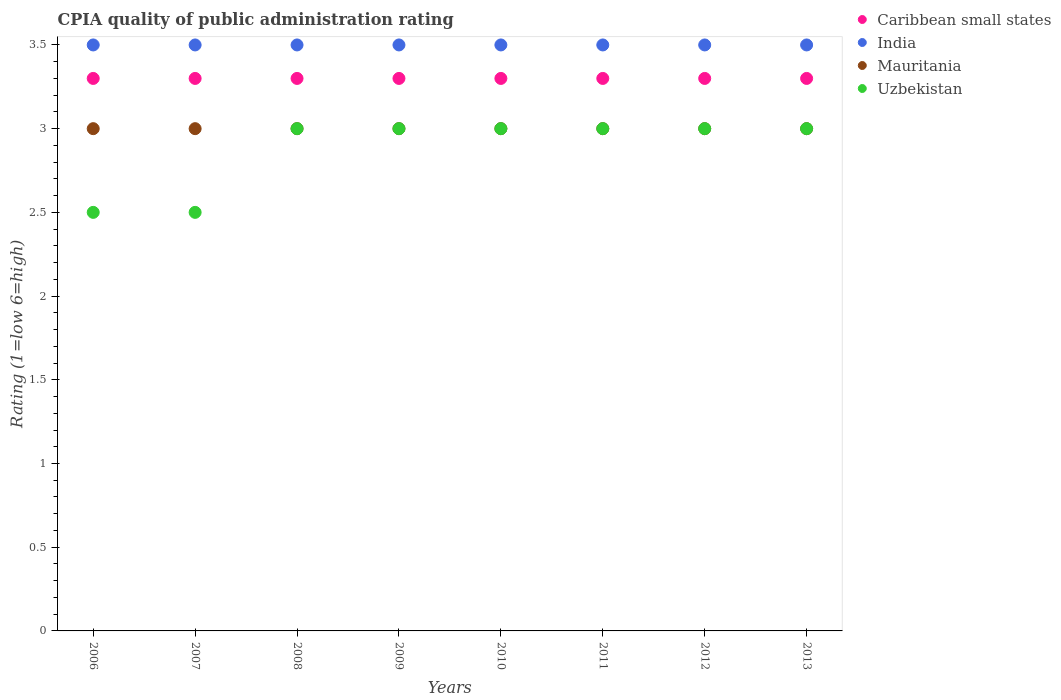How many different coloured dotlines are there?
Ensure brevity in your answer.  4. Is the number of dotlines equal to the number of legend labels?
Provide a succinct answer. Yes. Across all years, what is the maximum CPIA rating in Mauritania?
Offer a very short reply. 3. Across all years, what is the minimum CPIA rating in Mauritania?
Offer a terse response. 3. In which year was the CPIA rating in India minimum?
Ensure brevity in your answer.  2006. What is the difference between the CPIA rating in Caribbean small states in 2008 and the CPIA rating in Mauritania in 2010?
Keep it short and to the point. 0.3. In the year 2010, what is the difference between the CPIA rating in India and CPIA rating in Uzbekistan?
Make the answer very short. 0.5. In how many years, is the CPIA rating in Caribbean small states greater than 3.4?
Your answer should be compact. 0. What is the ratio of the CPIA rating in India in 2008 to that in 2009?
Make the answer very short. 1. Is the difference between the CPIA rating in India in 2007 and 2012 greater than the difference between the CPIA rating in Uzbekistan in 2007 and 2012?
Offer a terse response. Yes. What is the difference between the highest and the second highest CPIA rating in Caribbean small states?
Offer a very short reply. 0. Is it the case that in every year, the sum of the CPIA rating in Uzbekistan and CPIA rating in India  is greater than the sum of CPIA rating in Mauritania and CPIA rating in Caribbean small states?
Your answer should be compact. Yes. Is the CPIA rating in Caribbean small states strictly less than the CPIA rating in Uzbekistan over the years?
Your response must be concise. No. How many dotlines are there?
Your response must be concise. 4. Does the graph contain any zero values?
Offer a very short reply. No. How many legend labels are there?
Your answer should be very brief. 4. How are the legend labels stacked?
Make the answer very short. Vertical. What is the title of the graph?
Keep it short and to the point. CPIA quality of public administration rating. What is the label or title of the X-axis?
Provide a short and direct response. Years. What is the label or title of the Y-axis?
Give a very brief answer. Rating (1=low 6=high). What is the Rating (1=low 6=high) of India in 2006?
Offer a terse response. 3.5. What is the Rating (1=low 6=high) in India in 2007?
Your answer should be compact. 3.5. What is the Rating (1=low 6=high) of Mauritania in 2007?
Make the answer very short. 3. What is the Rating (1=low 6=high) of Caribbean small states in 2008?
Offer a very short reply. 3.3. What is the Rating (1=low 6=high) in India in 2008?
Provide a succinct answer. 3.5. What is the Rating (1=low 6=high) in Mauritania in 2008?
Offer a very short reply. 3. What is the Rating (1=low 6=high) of Mauritania in 2009?
Ensure brevity in your answer.  3. What is the Rating (1=low 6=high) in Uzbekistan in 2009?
Offer a terse response. 3. What is the Rating (1=low 6=high) in Uzbekistan in 2010?
Give a very brief answer. 3. What is the Rating (1=low 6=high) of Caribbean small states in 2011?
Keep it short and to the point. 3.3. What is the Rating (1=low 6=high) in India in 2011?
Offer a very short reply. 3.5. What is the Rating (1=low 6=high) in India in 2012?
Your response must be concise. 3.5. What is the Rating (1=low 6=high) of Mauritania in 2012?
Provide a succinct answer. 3. What is the Rating (1=low 6=high) of Caribbean small states in 2013?
Your answer should be compact. 3.3. What is the Rating (1=low 6=high) in India in 2013?
Make the answer very short. 3.5. Across all years, what is the maximum Rating (1=low 6=high) in Mauritania?
Offer a very short reply. 3. Across all years, what is the minimum Rating (1=low 6=high) in Caribbean small states?
Offer a terse response. 3.3. Across all years, what is the minimum Rating (1=low 6=high) in Uzbekistan?
Provide a succinct answer. 2.5. What is the total Rating (1=low 6=high) in Caribbean small states in the graph?
Your response must be concise. 26.4. What is the total Rating (1=low 6=high) in India in the graph?
Your answer should be very brief. 28. What is the difference between the Rating (1=low 6=high) of Caribbean small states in 2006 and that in 2007?
Your response must be concise. 0. What is the difference between the Rating (1=low 6=high) in India in 2006 and that in 2007?
Provide a succinct answer. 0. What is the difference between the Rating (1=low 6=high) in Mauritania in 2006 and that in 2007?
Provide a short and direct response. 0. What is the difference between the Rating (1=low 6=high) of Uzbekistan in 2006 and that in 2007?
Make the answer very short. 0. What is the difference between the Rating (1=low 6=high) in India in 2006 and that in 2008?
Provide a succinct answer. 0. What is the difference between the Rating (1=low 6=high) in Uzbekistan in 2006 and that in 2009?
Provide a succinct answer. -0.5. What is the difference between the Rating (1=low 6=high) in Caribbean small states in 2006 and that in 2010?
Provide a succinct answer. 0. What is the difference between the Rating (1=low 6=high) in India in 2006 and that in 2010?
Give a very brief answer. 0. What is the difference between the Rating (1=low 6=high) in Mauritania in 2006 and that in 2010?
Keep it short and to the point. 0. What is the difference between the Rating (1=low 6=high) in Uzbekistan in 2006 and that in 2011?
Your response must be concise. -0.5. What is the difference between the Rating (1=low 6=high) of Caribbean small states in 2006 and that in 2012?
Keep it short and to the point. 0. What is the difference between the Rating (1=low 6=high) of Mauritania in 2006 and that in 2012?
Give a very brief answer. 0. What is the difference between the Rating (1=low 6=high) of Uzbekistan in 2006 and that in 2012?
Provide a succinct answer. -0.5. What is the difference between the Rating (1=low 6=high) in Caribbean small states in 2006 and that in 2013?
Your answer should be very brief. 0. What is the difference between the Rating (1=low 6=high) in Mauritania in 2006 and that in 2013?
Make the answer very short. 0. What is the difference between the Rating (1=low 6=high) in Mauritania in 2007 and that in 2008?
Your answer should be very brief. 0. What is the difference between the Rating (1=low 6=high) in Caribbean small states in 2007 and that in 2009?
Your answer should be compact. 0. What is the difference between the Rating (1=low 6=high) in India in 2007 and that in 2009?
Give a very brief answer. 0. What is the difference between the Rating (1=low 6=high) in India in 2007 and that in 2010?
Your response must be concise. 0. What is the difference between the Rating (1=low 6=high) in Caribbean small states in 2007 and that in 2011?
Your answer should be very brief. 0. What is the difference between the Rating (1=low 6=high) in India in 2007 and that in 2011?
Your answer should be very brief. 0. What is the difference between the Rating (1=low 6=high) in Mauritania in 2007 and that in 2011?
Provide a succinct answer. 0. What is the difference between the Rating (1=low 6=high) in India in 2007 and that in 2012?
Provide a short and direct response. 0. What is the difference between the Rating (1=low 6=high) of Mauritania in 2007 and that in 2012?
Your answer should be very brief. 0. What is the difference between the Rating (1=low 6=high) of Mauritania in 2007 and that in 2013?
Make the answer very short. 0. What is the difference between the Rating (1=low 6=high) of Mauritania in 2008 and that in 2009?
Offer a very short reply. 0. What is the difference between the Rating (1=low 6=high) in Uzbekistan in 2008 and that in 2009?
Your answer should be very brief. 0. What is the difference between the Rating (1=low 6=high) of Caribbean small states in 2008 and that in 2010?
Your answer should be compact. 0. What is the difference between the Rating (1=low 6=high) in India in 2008 and that in 2010?
Provide a succinct answer. 0. What is the difference between the Rating (1=low 6=high) of Mauritania in 2008 and that in 2010?
Provide a succinct answer. 0. What is the difference between the Rating (1=low 6=high) in Caribbean small states in 2008 and that in 2011?
Give a very brief answer. 0. What is the difference between the Rating (1=low 6=high) of India in 2008 and that in 2011?
Make the answer very short. 0. What is the difference between the Rating (1=low 6=high) of Mauritania in 2008 and that in 2011?
Provide a succinct answer. 0. What is the difference between the Rating (1=low 6=high) of Uzbekistan in 2008 and that in 2011?
Provide a short and direct response. 0. What is the difference between the Rating (1=low 6=high) in India in 2008 and that in 2012?
Ensure brevity in your answer.  0. What is the difference between the Rating (1=low 6=high) of Uzbekistan in 2008 and that in 2012?
Ensure brevity in your answer.  0. What is the difference between the Rating (1=low 6=high) of Caribbean small states in 2008 and that in 2013?
Offer a terse response. 0. What is the difference between the Rating (1=low 6=high) of India in 2008 and that in 2013?
Keep it short and to the point. 0. What is the difference between the Rating (1=low 6=high) in Uzbekistan in 2008 and that in 2013?
Ensure brevity in your answer.  0. What is the difference between the Rating (1=low 6=high) in Caribbean small states in 2009 and that in 2010?
Keep it short and to the point. 0. What is the difference between the Rating (1=low 6=high) in India in 2009 and that in 2010?
Keep it short and to the point. 0. What is the difference between the Rating (1=low 6=high) of Caribbean small states in 2009 and that in 2011?
Ensure brevity in your answer.  0. What is the difference between the Rating (1=low 6=high) in Mauritania in 2009 and that in 2011?
Provide a short and direct response. 0. What is the difference between the Rating (1=low 6=high) of Uzbekistan in 2009 and that in 2011?
Provide a succinct answer. 0. What is the difference between the Rating (1=low 6=high) of Caribbean small states in 2009 and that in 2012?
Give a very brief answer. 0. What is the difference between the Rating (1=low 6=high) in India in 2009 and that in 2012?
Ensure brevity in your answer.  0. What is the difference between the Rating (1=low 6=high) in Mauritania in 2009 and that in 2012?
Provide a succinct answer. 0. What is the difference between the Rating (1=low 6=high) of Uzbekistan in 2009 and that in 2013?
Your answer should be compact. 0. What is the difference between the Rating (1=low 6=high) in India in 2010 and that in 2011?
Ensure brevity in your answer.  0. What is the difference between the Rating (1=low 6=high) in Uzbekistan in 2010 and that in 2011?
Give a very brief answer. 0. What is the difference between the Rating (1=low 6=high) of Caribbean small states in 2010 and that in 2012?
Provide a short and direct response. 0. What is the difference between the Rating (1=low 6=high) in Mauritania in 2010 and that in 2012?
Make the answer very short. 0. What is the difference between the Rating (1=low 6=high) of India in 2010 and that in 2013?
Give a very brief answer. 0. What is the difference between the Rating (1=low 6=high) in India in 2011 and that in 2012?
Your answer should be very brief. 0. What is the difference between the Rating (1=low 6=high) in Mauritania in 2011 and that in 2012?
Ensure brevity in your answer.  0. What is the difference between the Rating (1=low 6=high) of Caribbean small states in 2011 and that in 2013?
Make the answer very short. 0. What is the difference between the Rating (1=low 6=high) in Caribbean small states in 2012 and that in 2013?
Your answer should be very brief. 0. What is the difference between the Rating (1=low 6=high) in Mauritania in 2012 and that in 2013?
Offer a very short reply. 0. What is the difference between the Rating (1=low 6=high) in Uzbekistan in 2012 and that in 2013?
Offer a terse response. 0. What is the difference between the Rating (1=low 6=high) of Caribbean small states in 2006 and the Rating (1=low 6=high) of Mauritania in 2007?
Provide a succinct answer. 0.3. What is the difference between the Rating (1=low 6=high) in India in 2006 and the Rating (1=low 6=high) in Mauritania in 2007?
Provide a succinct answer. 0.5. What is the difference between the Rating (1=low 6=high) of India in 2006 and the Rating (1=low 6=high) of Uzbekistan in 2007?
Provide a succinct answer. 1. What is the difference between the Rating (1=low 6=high) of Mauritania in 2006 and the Rating (1=low 6=high) of Uzbekistan in 2007?
Provide a short and direct response. 0.5. What is the difference between the Rating (1=low 6=high) in Caribbean small states in 2006 and the Rating (1=low 6=high) in Mauritania in 2008?
Provide a succinct answer. 0.3. What is the difference between the Rating (1=low 6=high) of Caribbean small states in 2006 and the Rating (1=low 6=high) of Mauritania in 2009?
Your answer should be compact. 0.3. What is the difference between the Rating (1=low 6=high) of Caribbean small states in 2006 and the Rating (1=low 6=high) of Uzbekistan in 2009?
Provide a short and direct response. 0.3. What is the difference between the Rating (1=low 6=high) in India in 2006 and the Rating (1=low 6=high) in Mauritania in 2009?
Your answer should be very brief. 0.5. What is the difference between the Rating (1=low 6=high) in India in 2006 and the Rating (1=low 6=high) in Uzbekistan in 2009?
Offer a very short reply. 0.5. What is the difference between the Rating (1=low 6=high) in Caribbean small states in 2006 and the Rating (1=low 6=high) in India in 2010?
Provide a succinct answer. -0.2. What is the difference between the Rating (1=low 6=high) in Caribbean small states in 2006 and the Rating (1=low 6=high) in Uzbekistan in 2011?
Give a very brief answer. 0.3. What is the difference between the Rating (1=low 6=high) of India in 2006 and the Rating (1=low 6=high) of Mauritania in 2011?
Ensure brevity in your answer.  0.5. What is the difference between the Rating (1=low 6=high) of India in 2006 and the Rating (1=low 6=high) of Uzbekistan in 2011?
Your answer should be compact. 0.5. What is the difference between the Rating (1=low 6=high) of Mauritania in 2006 and the Rating (1=low 6=high) of Uzbekistan in 2011?
Your answer should be compact. 0. What is the difference between the Rating (1=low 6=high) in Caribbean small states in 2006 and the Rating (1=low 6=high) in India in 2012?
Give a very brief answer. -0.2. What is the difference between the Rating (1=low 6=high) in Caribbean small states in 2006 and the Rating (1=low 6=high) in Mauritania in 2012?
Provide a short and direct response. 0.3. What is the difference between the Rating (1=low 6=high) in Caribbean small states in 2006 and the Rating (1=low 6=high) in Uzbekistan in 2012?
Ensure brevity in your answer.  0.3. What is the difference between the Rating (1=low 6=high) in India in 2006 and the Rating (1=low 6=high) in Mauritania in 2012?
Provide a short and direct response. 0.5. What is the difference between the Rating (1=low 6=high) of India in 2006 and the Rating (1=low 6=high) of Uzbekistan in 2012?
Ensure brevity in your answer.  0.5. What is the difference between the Rating (1=low 6=high) in Caribbean small states in 2006 and the Rating (1=low 6=high) in India in 2013?
Keep it short and to the point. -0.2. What is the difference between the Rating (1=low 6=high) of Caribbean small states in 2006 and the Rating (1=low 6=high) of Mauritania in 2013?
Ensure brevity in your answer.  0.3. What is the difference between the Rating (1=low 6=high) of Caribbean small states in 2007 and the Rating (1=low 6=high) of Mauritania in 2008?
Make the answer very short. 0.3. What is the difference between the Rating (1=low 6=high) in India in 2007 and the Rating (1=low 6=high) in Mauritania in 2008?
Your response must be concise. 0.5. What is the difference between the Rating (1=low 6=high) in India in 2007 and the Rating (1=low 6=high) in Mauritania in 2009?
Provide a short and direct response. 0.5. What is the difference between the Rating (1=low 6=high) of India in 2007 and the Rating (1=low 6=high) of Uzbekistan in 2009?
Ensure brevity in your answer.  0.5. What is the difference between the Rating (1=low 6=high) of Caribbean small states in 2007 and the Rating (1=low 6=high) of India in 2010?
Provide a short and direct response. -0.2. What is the difference between the Rating (1=low 6=high) in Caribbean small states in 2007 and the Rating (1=low 6=high) in Mauritania in 2010?
Your response must be concise. 0.3. What is the difference between the Rating (1=low 6=high) in India in 2007 and the Rating (1=low 6=high) in Uzbekistan in 2010?
Keep it short and to the point. 0.5. What is the difference between the Rating (1=low 6=high) of Caribbean small states in 2007 and the Rating (1=low 6=high) of India in 2011?
Provide a short and direct response. -0.2. What is the difference between the Rating (1=low 6=high) in Caribbean small states in 2007 and the Rating (1=low 6=high) in Uzbekistan in 2011?
Your answer should be very brief. 0.3. What is the difference between the Rating (1=low 6=high) of India in 2007 and the Rating (1=low 6=high) of Uzbekistan in 2011?
Offer a terse response. 0.5. What is the difference between the Rating (1=low 6=high) in Caribbean small states in 2007 and the Rating (1=low 6=high) in India in 2012?
Offer a very short reply. -0.2. What is the difference between the Rating (1=low 6=high) of Caribbean small states in 2007 and the Rating (1=low 6=high) of Uzbekistan in 2012?
Offer a very short reply. 0.3. What is the difference between the Rating (1=low 6=high) in India in 2007 and the Rating (1=low 6=high) in Mauritania in 2012?
Give a very brief answer. 0.5. What is the difference between the Rating (1=low 6=high) in Caribbean small states in 2007 and the Rating (1=low 6=high) in India in 2013?
Your answer should be very brief. -0.2. What is the difference between the Rating (1=low 6=high) in Caribbean small states in 2007 and the Rating (1=low 6=high) in Mauritania in 2013?
Your answer should be compact. 0.3. What is the difference between the Rating (1=low 6=high) in Caribbean small states in 2007 and the Rating (1=low 6=high) in Uzbekistan in 2013?
Offer a very short reply. 0.3. What is the difference between the Rating (1=low 6=high) in Mauritania in 2007 and the Rating (1=low 6=high) in Uzbekistan in 2013?
Give a very brief answer. 0. What is the difference between the Rating (1=low 6=high) of Caribbean small states in 2008 and the Rating (1=low 6=high) of Mauritania in 2009?
Your answer should be very brief. 0.3. What is the difference between the Rating (1=low 6=high) in Caribbean small states in 2008 and the Rating (1=low 6=high) in Uzbekistan in 2009?
Make the answer very short. 0.3. What is the difference between the Rating (1=low 6=high) of India in 2008 and the Rating (1=low 6=high) of Mauritania in 2009?
Offer a terse response. 0.5. What is the difference between the Rating (1=low 6=high) in India in 2008 and the Rating (1=low 6=high) in Uzbekistan in 2009?
Your answer should be very brief. 0.5. What is the difference between the Rating (1=low 6=high) in Caribbean small states in 2008 and the Rating (1=low 6=high) in Mauritania in 2010?
Your answer should be very brief. 0.3. What is the difference between the Rating (1=low 6=high) in Caribbean small states in 2008 and the Rating (1=low 6=high) in Uzbekistan in 2010?
Ensure brevity in your answer.  0.3. What is the difference between the Rating (1=low 6=high) in India in 2008 and the Rating (1=low 6=high) in Uzbekistan in 2010?
Your answer should be compact. 0.5. What is the difference between the Rating (1=low 6=high) in Caribbean small states in 2008 and the Rating (1=low 6=high) in Mauritania in 2011?
Keep it short and to the point. 0.3. What is the difference between the Rating (1=low 6=high) of Caribbean small states in 2008 and the Rating (1=low 6=high) of Uzbekistan in 2011?
Keep it short and to the point. 0.3. What is the difference between the Rating (1=low 6=high) of India in 2008 and the Rating (1=low 6=high) of Uzbekistan in 2011?
Offer a terse response. 0.5. What is the difference between the Rating (1=low 6=high) of Mauritania in 2008 and the Rating (1=low 6=high) of Uzbekistan in 2011?
Your response must be concise. 0. What is the difference between the Rating (1=low 6=high) of Caribbean small states in 2008 and the Rating (1=low 6=high) of India in 2012?
Give a very brief answer. -0.2. What is the difference between the Rating (1=low 6=high) of Caribbean small states in 2008 and the Rating (1=low 6=high) of Mauritania in 2012?
Your response must be concise. 0.3. What is the difference between the Rating (1=low 6=high) of Mauritania in 2008 and the Rating (1=low 6=high) of Uzbekistan in 2012?
Offer a very short reply. 0. What is the difference between the Rating (1=low 6=high) of Caribbean small states in 2008 and the Rating (1=low 6=high) of Uzbekistan in 2013?
Provide a short and direct response. 0.3. What is the difference between the Rating (1=low 6=high) of India in 2008 and the Rating (1=low 6=high) of Mauritania in 2013?
Your answer should be very brief. 0.5. What is the difference between the Rating (1=low 6=high) in India in 2008 and the Rating (1=low 6=high) in Uzbekistan in 2013?
Your answer should be compact. 0.5. What is the difference between the Rating (1=low 6=high) of Mauritania in 2008 and the Rating (1=low 6=high) of Uzbekistan in 2013?
Provide a short and direct response. 0. What is the difference between the Rating (1=low 6=high) in Caribbean small states in 2009 and the Rating (1=low 6=high) in India in 2010?
Ensure brevity in your answer.  -0.2. What is the difference between the Rating (1=low 6=high) in Caribbean small states in 2009 and the Rating (1=low 6=high) in Uzbekistan in 2010?
Make the answer very short. 0.3. What is the difference between the Rating (1=low 6=high) in Caribbean small states in 2009 and the Rating (1=low 6=high) in Uzbekistan in 2011?
Offer a terse response. 0.3. What is the difference between the Rating (1=low 6=high) of India in 2009 and the Rating (1=low 6=high) of Mauritania in 2011?
Keep it short and to the point. 0.5. What is the difference between the Rating (1=low 6=high) in Mauritania in 2009 and the Rating (1=low 6=high) in Uzbekistan in 2011?
Offer a terse response. 0. What is the difference between the Rating (1=low 6=high) of Caribbean small states in 2009 and the Rating (1=low 6=high) of India in 2012?
Offer a very short reply. -0.2. What is the difference between the Rating (1=low 6=high) in India in 2009 and the Rating (1=low 6=high) in Mauritania in 2012?
Provide a short and direct response. 0.5. What is the difference between the Rating (1=low 6=high) of India in 2009 and the Rating (1=low 6=high) of Uzbekistan in 2012?
Give a very brief answer. 0.5. What is the difference between the Rating (1=low 6=high) of Caribbean small states in 2009 and the Rating (1=low 6=high) of India in 2013?
Keep it short and to the point. -0.2. What is the difference between the Rating (1=low 6=high) in Caribbean small states in 2009 and the Rating (1=low 6=high) in Mauritania in 2013?
Your answer should be compact. 0.3. What is the difference between the Rating (1=low 6=high) of India in 2009 and the Rating (1=low 6=high) of Mauritania in 2013?
Your answer should be very brief. 0.5. What is the difference between the Rating (1=low 6=high) in India in 2009 and the Rating (1=low 6=high) in Uzbekistan in 2013?
Ensure brevity in your answer.  0.5. What is the difference between the Rating (1=low 6=high) in Mauritania in 2009 and the Rating (1=low 6=high) in Uzbekistan in 2013?
Provide a succinct answer. 0. What is the difference between the Rating (1=low 6=high) in Caribbean small states in 2010 and the Rating (1=low 6=high) in India in 2011?
Provide a short and direct response. -0.2. What is the difference between the Rating (1=low 6=high) in Mauritania in 2010 and the Rating (1=low 6=high) in Uzbekistan in 2011?
Make the answer very short. 0. What is the difference between the Rating (1=low 6=high) of Caribbean small states in 2010 and the Rating (1=low 6=high) of India in 2012?
Your answer should be very brief. -0.2. What is the difference between the Rating (1=low 6=high) in Caribbean small states in 2010 and the Rating (1=low 6=high) in Mauritania in 2012?
Offer a terse response. 0.3. What is the difference between the Rating (1=low 6=high) in Caribbean small states in 2010 and the Rating (1=low 6=high) in Uzbekistan in 2012?
Give a very brief answer. 0.3. What is the difference between the Rating (1=low 6=high) of India in 2010 and the Rating (1=low 6=high) of Mauritania in 2012?
Give a very brief answer. 0.5. What is the difference between the Rating (1=low 6=high) in India in 2010 and the Rating (1=low 6=high) in Uzbekistan in 2012?
Give a very brief answer. 0.5. What is the difference between the Rating (1=low 6=high) in Mauritania in 2010 and the Rating (1=low 6=high) in Uzbekistan in 2012?
Offer a terse response. 0. What is the difference between the Rating (1=low 6=high) of Caribbean small states in 2010 and the Rating (1=low 6=high) of India in 2013?
Provide a short and direct response. -0.2. What is the difference between the Rating (1=low 6=high) in Caribbean small states in 2010 and the Rating (1=low 6=high) in Mauritania in 2013?
Provide a succinct answer. 0.3. What is the difference between the Rating (1=low 6=high) in Caribbean small states in 2010 and the Rating (1=low 6=high) in Uzbekistan in 2013?
Provide a short and direct response. 0.3. What is the difference between the Rating (1=low 6=high) of India in 2010 and the Rating (1=low 6=high) of Mauritania in 2013?
Provide a succinct answer. 0.5. What is the difference between the Rating (1=low 6=high) of Mauritania in 2010 and the Rating (1=low 6=high) of Uzbekistan in 2013?
Keep it short and to the point. 0. What is the difference between the Rating (1=low 6=high) of Caribbean small states in 2011 and the Rating (1=low 6=high) of Uzbekistan in 2012?
Make the answer very short. 0.3. What is the difference between the Rating (1=low 6=high) of India in 2011 and the Rating (1=low 6=high) of Uzbekistan in 2012?
Your answer should be very brief. 0.5. What is the difference between the Rating (1=low 6=high) of Mauritania in 2011 and the Rating (1=low 6=high) of Uzbekistan in 2012?
Provide a succinct answer. 0. What is the difference between the Rating (1=low 6=high) in Caribbean small states in 2011 and the Rating (1=low 6=high) in India in 2013?
Provide a short and direct response. -0.2. What is the difference between the Rating (1=low 6=high) of Caribbean small states in 2011 and the Rating (1=low 6=high) of Mauritania in 2013?
Your answer should be very brief. 0.3. What is the difference between the Rating (1=low 6=high) of India in 2011 and the Rating (1=low 6=high) of Mauritania in 2013?
Keep it short and to the point. 0.5. What is the difference between the Rating (1=low 6=high) of India in 2011 and the Rating (1=low 6=high) of Uzbekistan in 2013?
Ensure brevity in your answer.  0.5. What is the difference between the Rating (1=low 6=high) of Mauritania in 2011 and the Rating (1=low 6=high) of Uzbekistan in 2013?
Your response must be concise. 0. What is the difference between the Rating (1=low 6=high) of Caribbean small states in 2012 and the Rating (1=low 6=high) of India in 2013?
Your answer should be compact. -0.2. What is the difference between the Rating (1=low 6=high) in Caribbean small states in 2012 and the Rating (1=low 6=high) in Uzbekistan in 2013?
Keep it short and to the point. 0.3. What is the difference between the Rating (1=low 6=high) in India in 2012 and the Rating (1=low 6=high) in Mauritania in 2013?
Give a very brief answer. 0.5. What is the difference between the Rating (1=low 6=high) of Mauritania in 2012 and the Rating (1=low 6=high) of Uzbekistan in 2013?
Offer a very short reply. 0. What is the average Rating (1=low 6=high) of Caribbean small states per year?
Offer a very short reply. 3.3. What is the average Rating (1=low 6=high) in India per year?
Ensure brevity in your answer.  3.5. What is the average Rating (1=low 6=high) of Uzbekistan per year?
Offer a very short reply. 2.88. In the year 2006, what is the difference between the Rating (1=low 6=high) of Caribbean small states and Rating (1=low 6=high) of India?
Provide a short and direct response. -0.2. In the year 2006, what is the difference between the Rating (1=low 6=high) in Caribbean small states and Rating (1=low 6=high) in Uzbekistan?
Keep it short and to the point. 0.8. In the year 2007, what is the difference between the Rating (1=low 6=high) in Caribbean small states and Rating (1=low 6=high) in Uzbekistan?
Offer a very short reply. 0.8. In the year 2007, what is the difference between the Rating (1=low 6=high) of India and Rating (1=low 6=high) of Mauritania?
Your response must be concise. 0.5. In the year 2008, what is the difference between the Rating (1=low 6=high) of Caribbean small states and Rating (1=low 6=high) of India?
Offer a very short reply. -0.2. In the year 2008, what is the difference between the Rating (1=low 6=high) of India and Rating (1=low 6=high) of Mauritania?
Provide a succinct answer. 0.5. In the year 2008, what is the difference between the Rating (1=low 6=high) of India and Rating (1=low 6=high) of Uzbekistan?
Provide a succinct answer. 0.5. In the year 2009, what is the difference between the Rating (1=low 6=high) in Caribbean small states and Rating (1=low 6=high) in India?
Give a very brief answer. -0.2. In the year 2009, what is the difference between the Rating (1=low 6=high) of Caribbean small states and Rating (1=low 6=high) of Mauritania?
Your response must be concise. 0.3. In the year 2009, what is the difference between the Rating (1=low 6=high) in India and Rating (1=low 6=high) in Uzbekistan?
Make the answer very short. 0.5. In the year 2010, what is the difference between the Rating (1=low 6=high) of Caribbean small states and Rating (1=low 6=high) of India?
Make the answer very short. -0.2. In the year 2010, what is the difference between the Rating (1=low 6=high) in Caribbean small states and Rating (1=low 6=high) in Mauritania?
Make the answer very short. 0.3. In the year 2010, what is the difference between the Rating (1=low 6=high) of India and Rating (1=low 6=high) of Mauritania?
Offer a terse response. 0.5. In the year 2011, what is the difference between the Rating (1=low 6=high) of Caribbean small states and Rating (1=low 6=high) of India?
Your response must be concise. -0.2. In the year 2011, what is the difference between the Rating (1=low 6=high) in Caribbean small states and Rating (1=low 6=high) in Uzbekistan?
Provide a succinct answer. 0.3. In the year 2011, what is the difference between the Rating (1=low 6=high) in India and Rating (1=low 6=high) in Mauritania?
Offer a very short reply. 0.5. In the year 2011, what is the difference between the Rating (1=low 6=high) in India and Rating (1=low 6=high) in Uzbekistan?
Your response must be concise. 0.5. In the year 2012, what is the difference between the Rating (1=low 6=high) in Caribbean small states and Rating (1=low 6=high) in Mauritania?
Give a very brief answer. 0.3. In the year 2012, what is the difference between the Rating (1=low 6=high) of Caribbean small states and Rating (1=low 6=high) of Uzbekistan?
Give a very brief answer. 0.3. In the year 2012, what is the difference between the Rating (1=low 6=high) in Mauritania and Rating (1=low 6=high) in Uzbekistan?
Ensure brevity in your answer.  0. In the year 2013, what is the difference between the Rating (1=low 6=high) of Caribbean small states and Rating (1=low 6=high) of Mauritania?
Provide a short and direct response. 0.3. In the year 2013, what is the difference between the Rating (1=low 6=high) in India and Rating (1=low 6=high) in Mauritania?
Make the answer very short. 0.5. In the year 2013, what is the difference between the Rating (1=low 6=high) of India and Rating (1=low 6=high) of Uzbekistan?
Give a very brief answer. 0.5. What is the ratio of the Rating (1=low 6=high) in Caribbean small states in 2006 to that in 2007?
Offer a very short reply. 1. What is the ratio of the Rating (1=low 6=high) in India in 2006 to that in 2007?
Your response must be concise. 1. What is the ratio of the Rating (1=low 6=high) of Caribbean small states in 2006 to that in 2008?
Your answer should be very brief. 1. What is the ratio of the Rating (1=low 6=high) of India in 2006 to that in 2008?
Provide a short and direct response. 1. What is the ratio of the Rating (1=low 6=high) in Uzbekistan in 2006 to that in 2008?
Provide a short and direct response. 0.83. What is the ratio of the Rating (1=low 6=high) in Mauritania in 2006 to that in 2009?
Provide a succinct answer. 1. What is the ratio of the Rating (1=low 6=high) in Uzbekistan in 2006 to that in 2009?
Offer a terse response. 0.83. What is the ratio of the Rating (1=low 6=high) of Caribbean small states in 2006 to that in 2010?
Make the answer very short. 1. What is the ratio of the Rating (1=low 6=high) in India in 2006 to that in 2010?
Ensure brevity in your answer.  1. What is the ratio of the Rating (1=low 6=high) of Uzbekistan in 2006 to that in 2010?
Provide a short and direct response. 0.83. What is the ratio of the Rating (1=low 6=high) of Caribbean small states in 2006 to that in 2011?
Offer a very short reply. 1. What is the ratio of the Rating (1=low 6=high) of Mauritania in 2006 to that in 2011?
Offer a terse response. 1. What is the ratio of the Rating (1=low 6=high) of Uzbekistan in 2006 to that in 2011?
Offer a very short reply. 0.83. What is the ratio of the Rating (1=low 6=high) in Caribbean small states in 2006 to that in 2012?
Provide a short and direct response. 1. What is the ratio of the Rating (1=low 6=high) of Uzbekistan in 2006 to that in 2012?
Your answer should be very brief. 0.83. What is the ratio of the Rating (1=low 6=high) of India in 2006 to that in 2013?
Keep it short and to the point. 1. What is the ratio of the Rating (1=low 6=high) of Uzbekistan in 2006 to that in 2013?
Make the answer very short. 0.83. What is the ratio of the Rating (1=low 6=high) of India in 2007 to that in 2008?
Keep it short and to the point. 1. What is the ratio of the Rating (1=low 6=high) of Mauritania in 2007 to that in 2008?
Provide a succinct answer. 1. What is the ratio of the Rating (1=low 6=high) of Uzbekistan in 2007 to that in 2008?
Your answer should be very brief. 0.83. What is the ratio of the Rating (1=low 6=high) in Caribbean small states in 2007 to that in 2009?
Keep it short and to the point. 1. What is the ratio of the Rating (1=low 6=high) in India in 2007 to that in 2009?
Ensure brevity in your answer.  1. What is the ratio of the Rating (1=low 6=high) in Caribbean small states in 2007 to that in 2010?
Your answer should be very brief. 1. What is the ratio of the Rating (1=low 6=high) of India in 2007 to that in 2010?
Ensure brevity in your answer.  1. What is the ratio of the Rating (1=low 6=high) in Mauritania in 2007 to that in 2010?
Your answer should be very brief. 1. What is the ratio of the Rating (1=low 6=high) of Uzbekistan in 2007 to that in 2010?
Provide a succinct answer. 0.83. What is the ratio of the Rating (1=low 6=high) of Caribbean small states in 2007 to that in 2011?
Make the answer very short. 1. What is the ratio of the Rating (1=low 6=high) in Mauritania in 2007 to that in 2011?
Provide a succinct answer. 1. What is the ratio of the Rating (1=low 6=high) of Uzbekistan in 2007 to that in 2011?
Provide a succinct answer. 0.83. What is the ratio of the Rating (1=low 6=high) in India in 2007 to that in 2012?
Make the answer very short. 1. What is the ratio of the Rating (1=low 6=high) in Mauritania in 2007 to that in 2012?
Give a very brief answer. 1. What is the ratio of the Rating (1=low 6=high) in Caribbean small states in 2007 to that in 2013?
Keep it short and to the point. 1. What is the ratio of the Rating (1=low 6=high) of Uzbekistan in 2007 to that in 2013?
Ensure brevity in your answer.  0.83. What is the ratio of the Rating (1=low 6=high) of Caribbean small states in 2008 to that in 2009?
Keep it short and to the point. 1. What is the ratio of the Rating (1=low 6=high) in India in 2008 to that in 2009?
Make the answer very short. 1. What is the ratio of the Rating (1=low 6=high) of Uzbekistan in 2008 to that in 2009?
Your answer should be compact. 1. What is the ratio of the Rating (1=low 6=high) of Uzbekistan in 2008 to that in 2010?
Your answer should be compact. 1. What is the ratio of the Rating (1=low 6=high) in Uzbekistan in 2008 to that in 2011?
Make the answer very short. 1. What is the ratio of the Rating (1=low 6=high) in Uzbekistan in 2008 to that in 2012?
Ensure brevity in your answer.  1. What is the ratio of the Rating (1=low 6=high) of Caribbean small states in 2008 to that in 2013?
Keep it short and to the point. 1. What is the ratio of the Rating (1=low 6=high) of India in 2008 to that in 2013?
Make the answer very short. 1. What is the ratio of the Rating (1=low 6=high) in Mauritania in 2008 to that in 2013?
Ensure brevity in your answer.  1. What is the ratio of the Rating (1=low 6=high) in Caribbean small states in 2009 to that in 2010?
Provide a short and direct response. 1. What is the ratio of the Rating (1=low 6=high) of Mauritania in 2009 to that in 2011?
Offer a terse response. 1. What is the ratio of the Rating (1=low 6=high) in India in 2009 to that in 2012?
Offer a very short reply. 1. What is the ratio of the Rating (1=low 6=high) in Uzbekistan in 2009 to that in 2012?
Ensure brevity in your answer.  1. What is the ratio of the Rating (1=low 6=high) in India in 2009 to that in 2013?
Keep it short and to the point. 1. What is the ratio of the Rating (1=low 6=high) in Mauritania in 2009 to that in 2013?
Your answer should be very brief. 1. What is the ratio of the Rating (1=low 6=high) of Caribbean small states in 2010 to that in 2011?
Give a very brief answer. 1. What is the ratio of the Rating (1=low 6=high) of Uzbekistan in 2010 to that in 2011?
Your response must be concise. 1. What is the ratio of the Rating (1=low 6=high) in Caribbean small states in 2010 to that in 2012?
Offer a terse response. 1. What is the ratio of the Rating (1=low 6=high) in Uzbekistan in 2010 to that in 2012?
Ensure brevity in your answer.  1. What is the ratio of the Rating (1=low 6=high) in Caribbean small states in 2010 to that in 2013?
Provide a short and direct response. 1. What is the ratio of the Rating (1=low 6=high) of India in 2010 to that in 2013?
Provide a succinct answer. 1. What is the ratio of the Rating (1=low 6=high) of Uzbekistan in 2010 to that in 2013?
Keep it short and to the point. 1. What is the ratio of the Rating (1=low 6=high) of Caribbean small states in 2011 to that in 2012?
Keep it short and to the point. 1. What is the ratio of the Rating (1=low 6=high) of Mauritania in 2011 to that in 2012?
Ensure brevity in your answer.  1. What is the ratio of the Rating (1=low 6=high) of Mauritania in 2011 to that in 2013?
Your answer should be very brief. 1. What is the ratio of the Rating (1=low 6=high) in Caribbean small states in 2012 to that in 2013?
Provide a short and direct response. 1. What is the ratio of the Rating (1=low 6=high) in India in 2012 to that in 2013?
Offer a terse response. 1. What is the difference between the highest and the second highest Rating (1=low 6=high) of India?
Keep it short and to the point. 0. What is the difference between the highest and the second highest Rating (1=low 6=high) in Mauritania?
Your answer should be compact. 0. What is the difference between the highest and the second highest Rating (1=low 6=high) of Uzbekistan?
Provide a succinct answer. 0. What is the difference between the highest and the lowest Rating (1=low 6=high) in Caribbean small states?
Your answer should be compact. 0. What is the difference between the highest and the lowest Rating (1=low 6=high) in Mauritania?
Provide a short and direct response. 0. What is the difference between the highest and the lowest Rating (1=low 6=high) in Uzbekistan?
Provide a short and direct response. 0.5. 